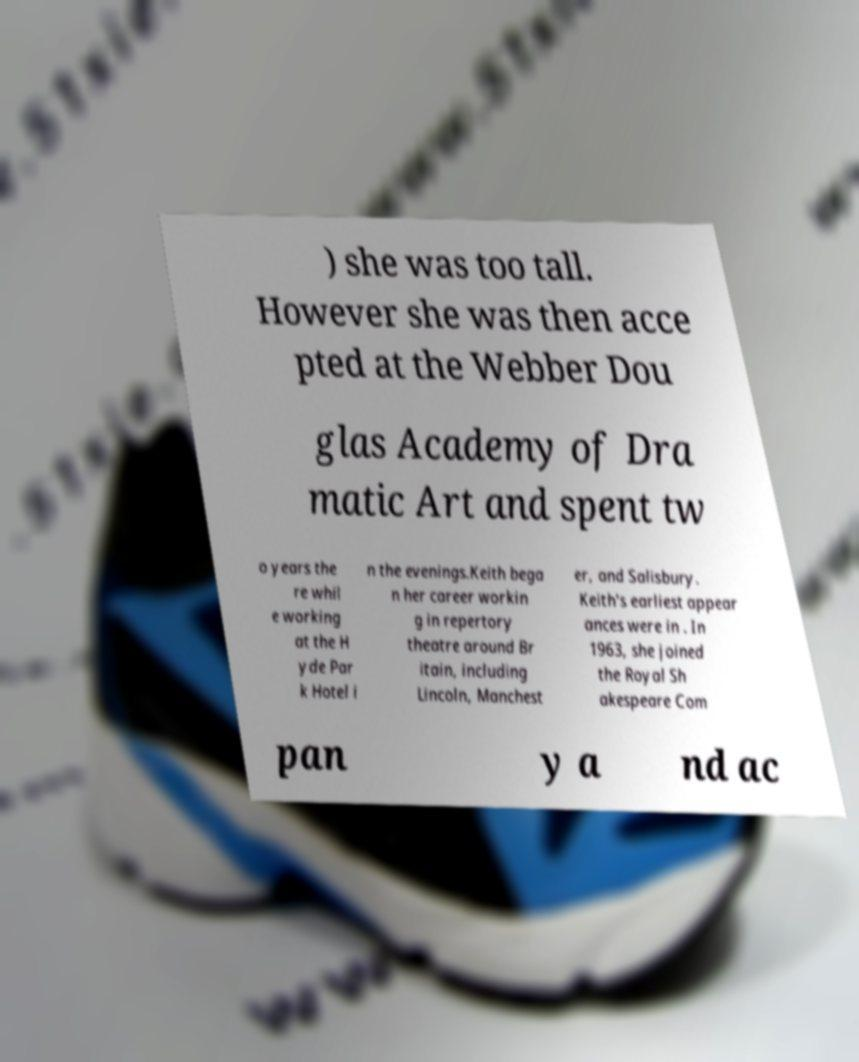Can you accurately transcribe the text from the provided image for me? ) she was too tall. However she was then acce pted at the Webber Dou glas Academy of Dra matic Art and spent tw o years the re whil e working at the H yde Par k Hotel i n the evenings.Keith bega n her career workin g in repertory theatre around Br itain, including Lincoln, Manchest er, and Salisbury. Keith's earliest appear ances were in . In 1963, she joined the Royal Sh akespeare Com pan y a nd ac 